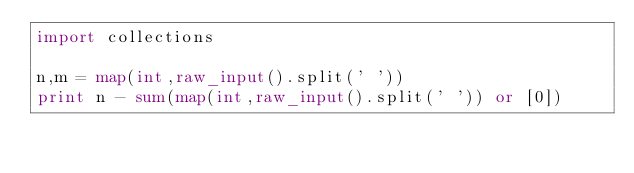<code> <loc_0><loc_0><loc_500><loc_500><_Python_>import collections
 
n,m = map(int,raw_input().split(' '))
print n - sum(map(int,raw_input().split(' ')) or [0])</code> 